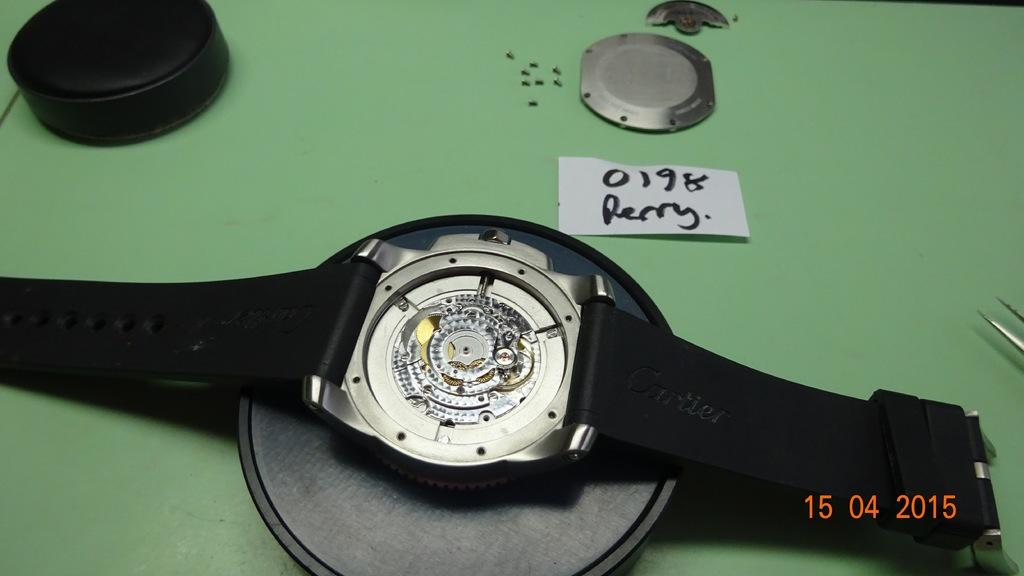Provide a one-sentence caption for the provided image. A Perry watch model number 0198 is being worked on in 2015. 